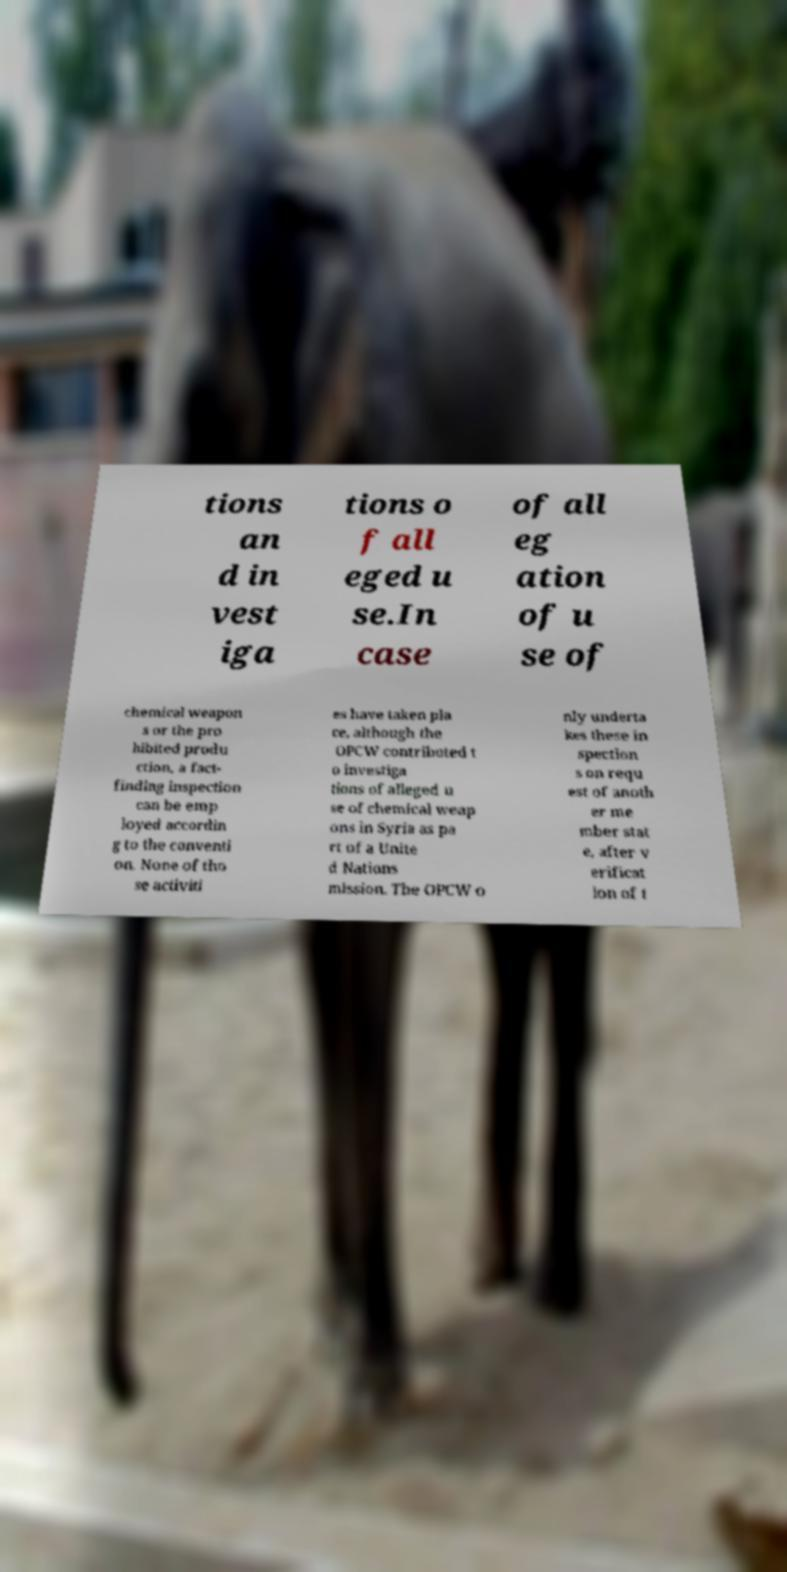Could you assist in decoding the text presented in this image and type it out clearly? tions an d in vest iga tions o f all eged u se.In case of all eg ation of u se of chemical weapon s or the pro hibited produ ction, a fact- finding inspection can be emp loyed accordin g to the conventi on. None of tho se activiti es have taken pla ce, although the OPCW contributed t o investiga tions of alleged u se of chemical weap ons in Syria as pa rt of a Unite d Nations mission. The OPCW o nly underta kes these in spection s on requ est of anoth er me mber stat e, after v erificat ion of t 